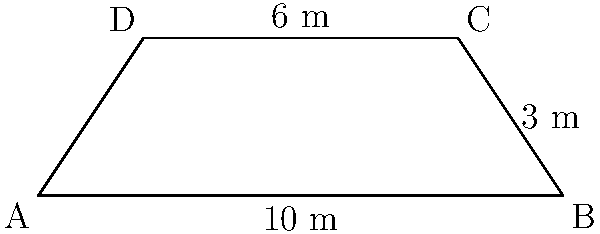A traditional Maori waka (canoe) hull has a trapezoidal cross-section as shown in the diagram. The base is 10 meters long, the top is 6 meters long, and the height is 3 meters. Calculate the surface area of one side of the hull, excluding the top and bottom surfaces. To calculate the surface area of one side of the hull, we need to find the length of the slanted side and multiply it by the length of the hull.

1. First, let's find the length of the slanted side using the Pythagorean theorem:
   $$\text{Slant length} = \sqrt{(\frac{10-6}{2})^2 + 3^2} = \sqrt{2^2 + 3^2} = \sqrt{4 + 9} = \sqrt{13}$$

2. Now, we need to calculate the length of the hull. In this case, it's given as 10 meters (the base length).

3. The surface area of one side is the product of the slant length and the hull length:
   $$\text{Surface Area} = \sqrt{13} \times 10 = 10\sqrt{13}$$

Therefore, the surface area of one side of the hull is $10\sqrt{13}$ square meters.
Answer: $10\sqrt{13}$ m² 